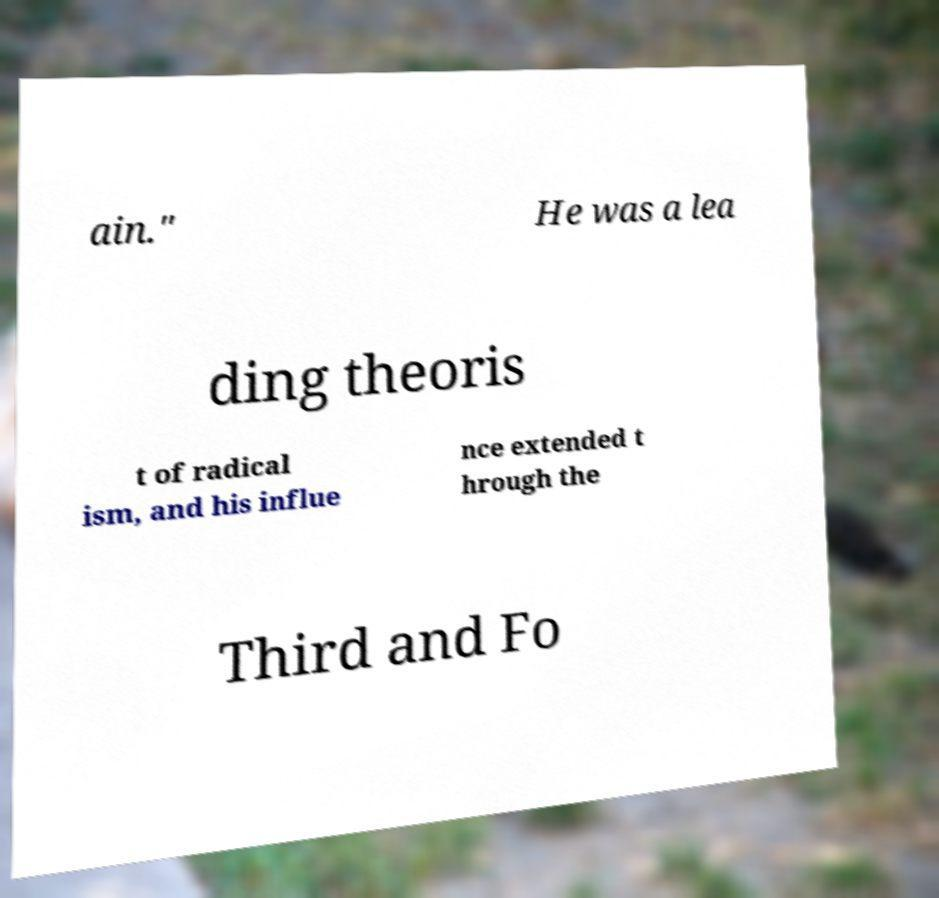Can you accurately transcribe the text from the provided image for me? ain." He was a lea ding theoris t of radical ism, and his influe nce extended t hrough the Third and Fo 